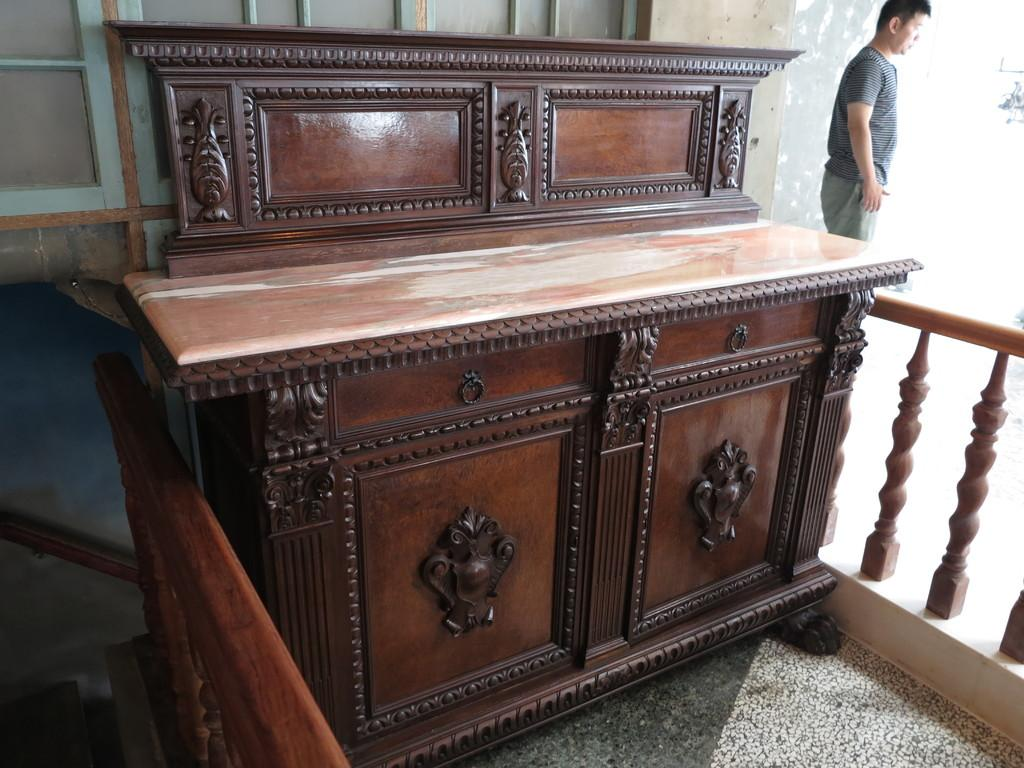What type of object is the main subject in the image? There is a brown color wooden box in the image. Can you describe the person in the image? There is a person standing at the right side of the image. What effect does the sister have on the wooden box in the image? There is no mention of a sister in the image, so it is not possible to determine any effect she might have on the wooden box. What type of tooth can be seen in the image? There is no tooth present in the image. 